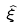<formula> <loc_0><loc_0><loc_500><loc_500>\hat { \xi }</formula> 